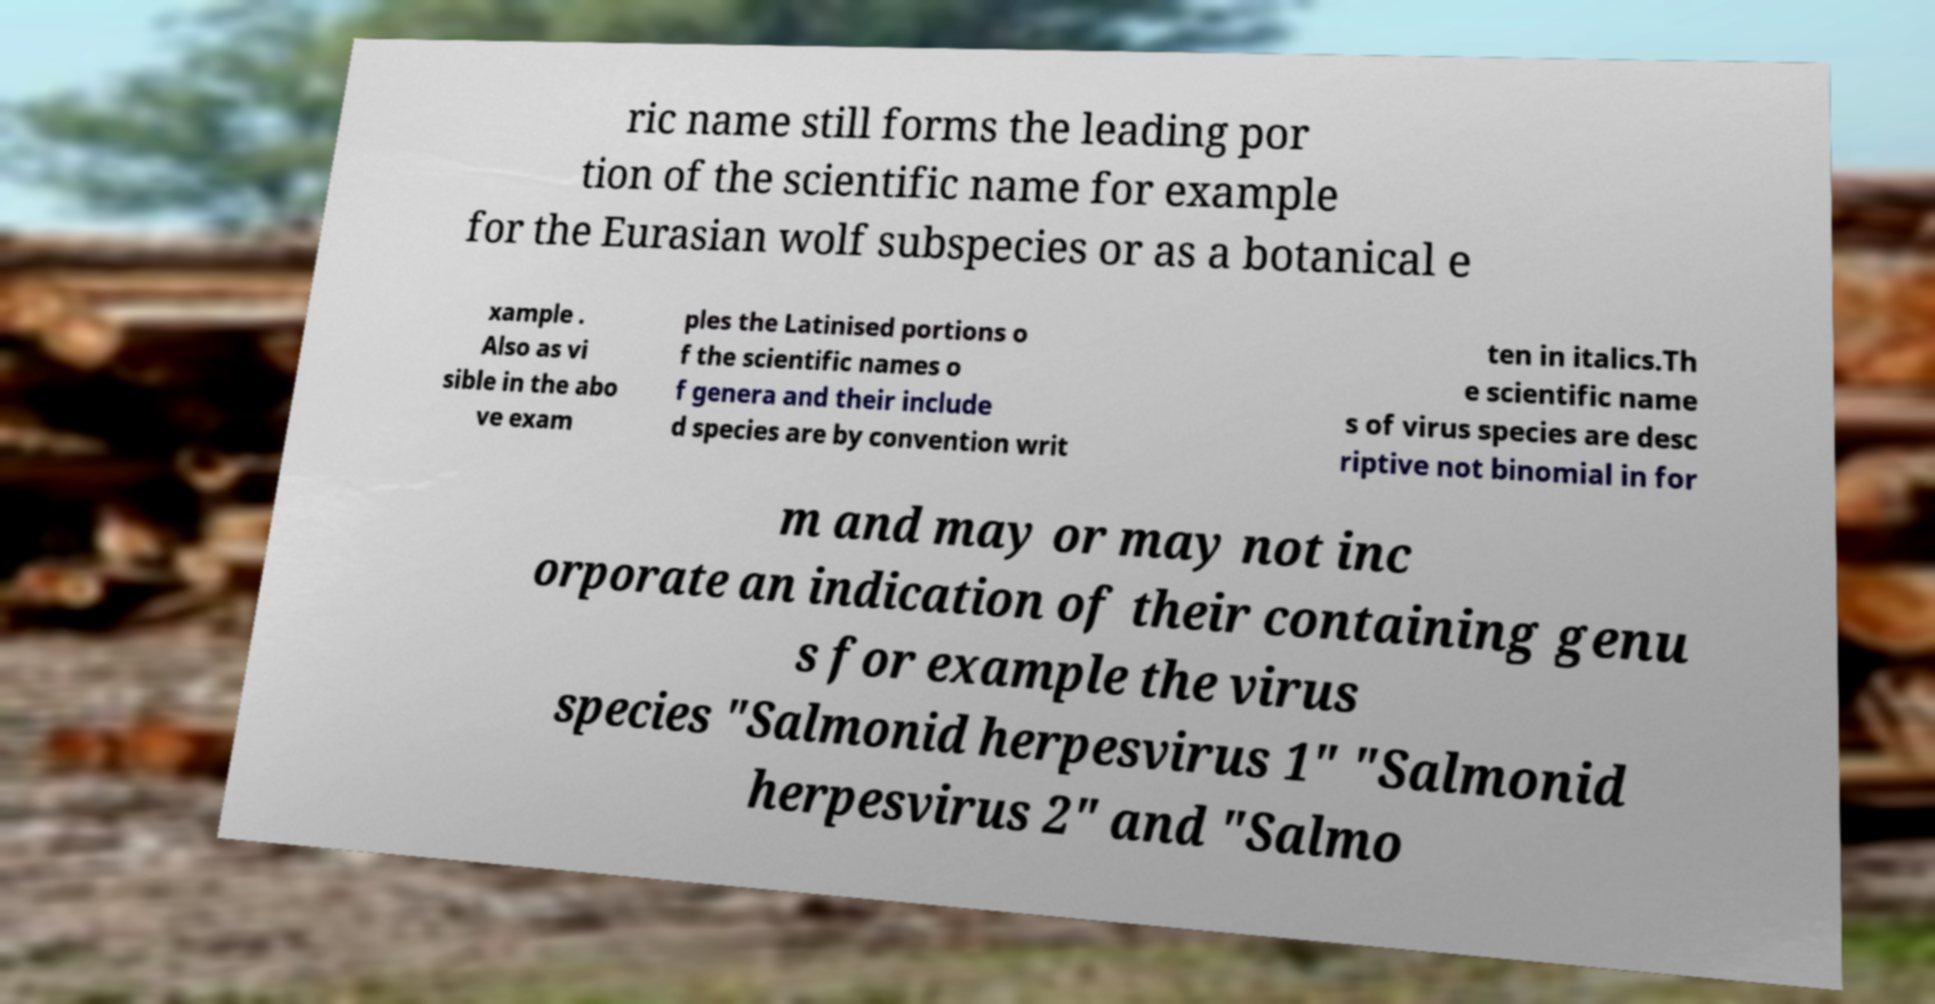Please identify and transcribe the text found in this image. ric name still forms the leading por tion of the scientific name for example for the Eurasian wolf subspecies or as a botanical e xample . Also as vi sible in the abo ve exam ples the Latinised portions o f the scientific names o f genera and their include d species are by convention writ ten in italics.Th e scientific name s of virus species are desc riptive not binomial in for m and may or may not inc orporate an indication of their containing genu s for example the virus species "Salmonid herpesvirus 1" "Salmonid herpesvirus 2" and "Salmo 